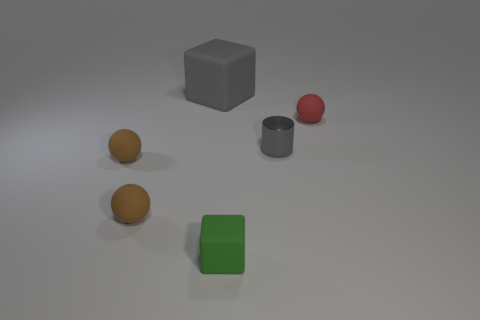Add 1 small red matte objects. How many objects exist? 7 Subtract all cylinders. How many objects are left? 5 Add 2 large gray cubes. How many large gray cubes are left? 3 Add 6 green rubber cylinders. How many green rubber cylinders exist? 6 Subtract 1 gray cylinders. How many objects are left? 5 Subtract all big objects. Subtract all green things. How many objects are left? 4 